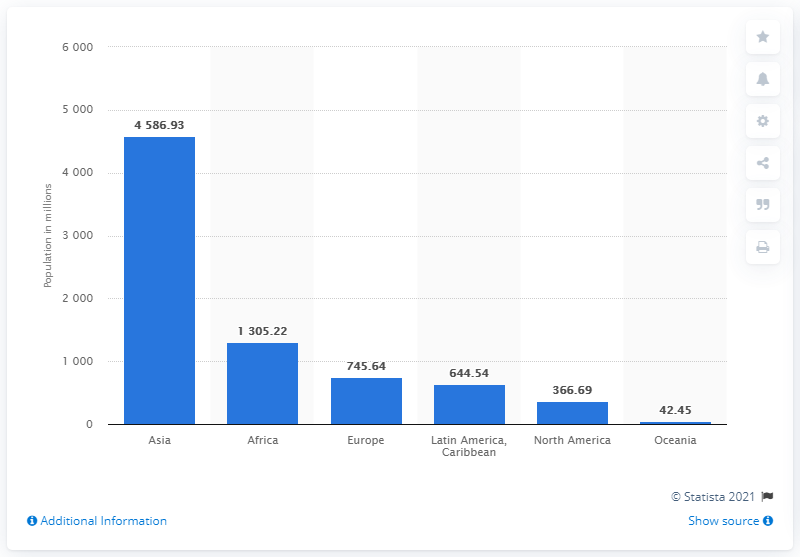Highlight a few significant elements in this photo. As of mid-2019, it is estimated that approximately 4586.93 people lived in Asia. 